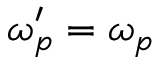<formula> <loc_0><loc_0><loc_500><loc_500>\omega _ { p } ^ { \prime } = \omega _ { p }</formula> 